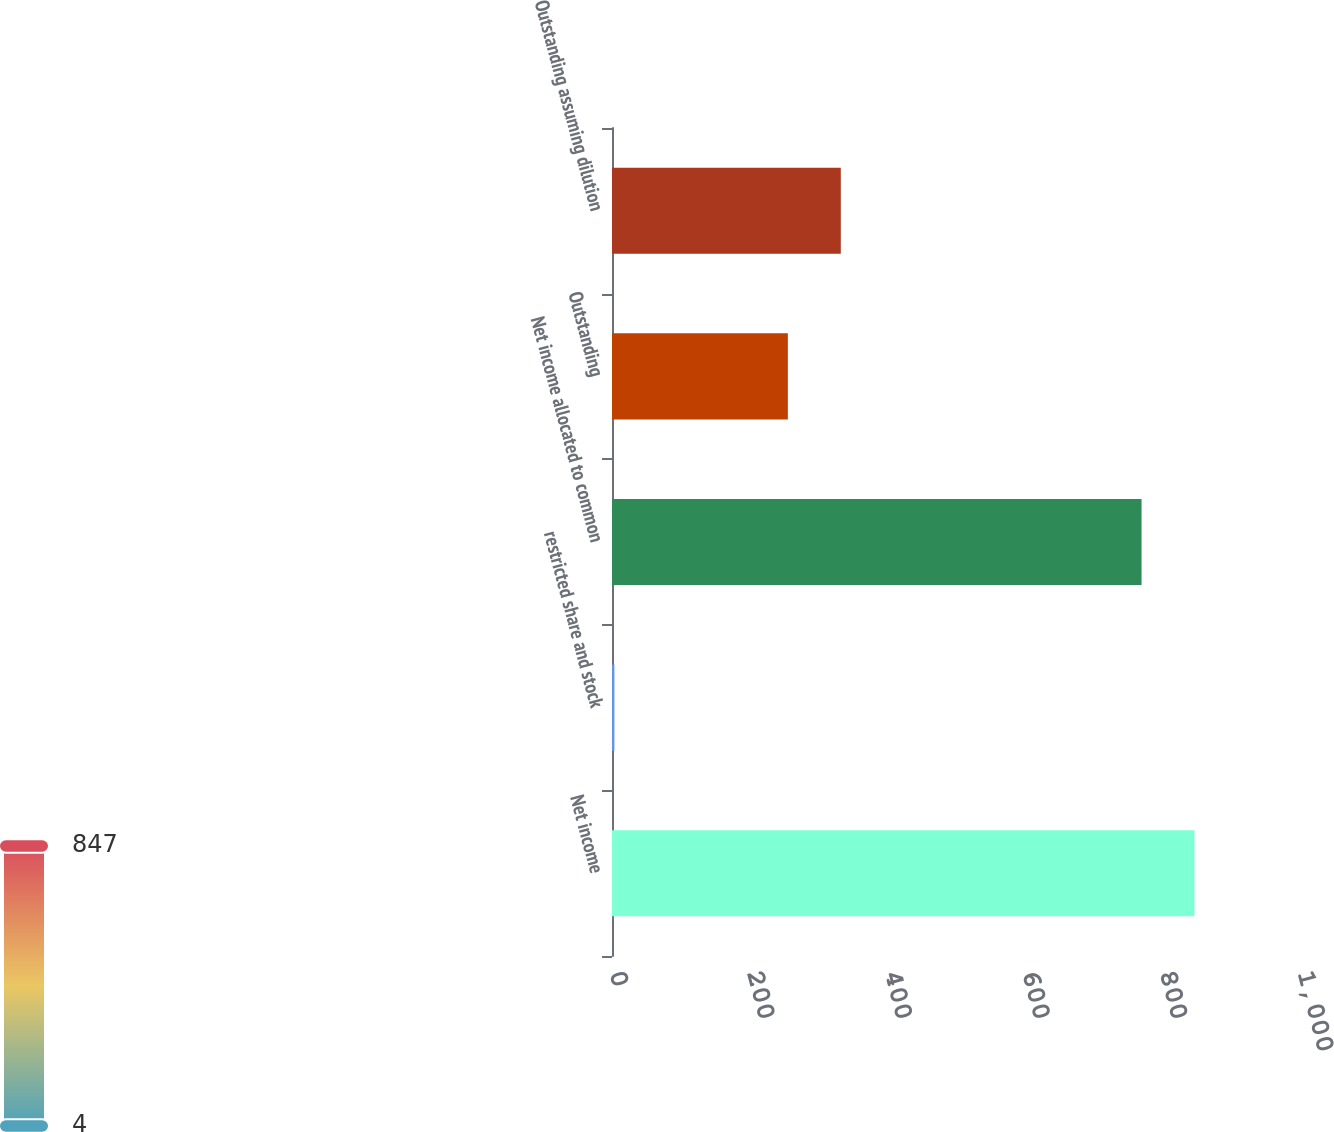<chart> <loc_0><loc_0><loc_500><loc_500><bar_chart><fcel>Net income<fcel>restricted share and stock<fcel>Net income allocated to common<fcel>Outstanding<fcel>Outstanding assuming dilution<nl><fcel>846.67<fcel>3.5<fcel>769.7<fcel>255.6<fcel>332.57<nl></chart> 